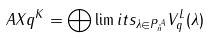Convert formula to latex. <formula><loc_0><loc_0><loc_500><loc_500>\ A X q ^ { K } = \bigoplus \lim i t s _ { \lambda \in P ^ { \mathcal { A } } _ { n } } V _ { q } ^ { L } ( \lambda )</formula> 